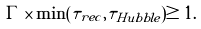Convert formula to latex. <formula><loc_0><loc_0><loc_500><loc_500>\Gamma \times \min ( \tau _ { r e c } , \tau _ { H u b b l e } ) \geq 1 .</formula> 